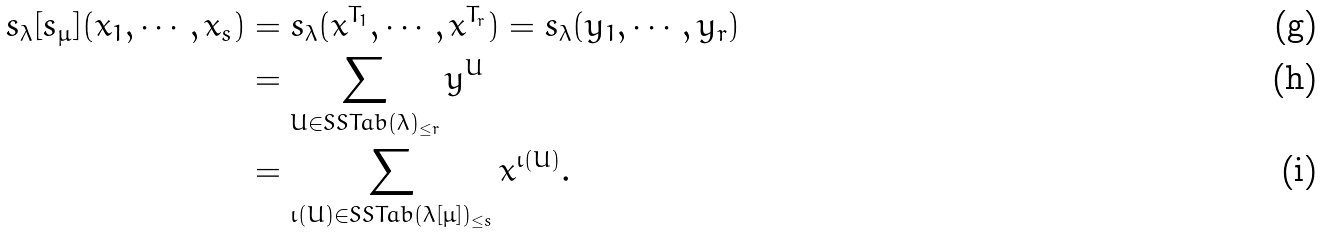<formula> <loc_0><loc_0><loc_500><loc_500>s _ { \lambda } [ s _ { \mu } ] ( x _ { 1 } , \cdots , x _ { s } ) & = s _ { \lambda } ( x ^ { T _ { 1 } } , \cdots , x ^ { T _ { r } } ) = s _ { \lambda } ( y _ { 1 } , \cdots , y _ { r } ) \\ & = \sum _ { U \in S S T a b ( \lambda ) _ { \leq r } } y ^ { U } \\ & = \sum _ { \iota ( U ) \in S S T a b ( \lambda [ \mu ] ) _ { \leq s } } x ^ { \iota ( U ) } .</formula> 